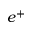<formula> <loc_0><loc_0><loc_500><loc_500>e ^ { + }</formula> 